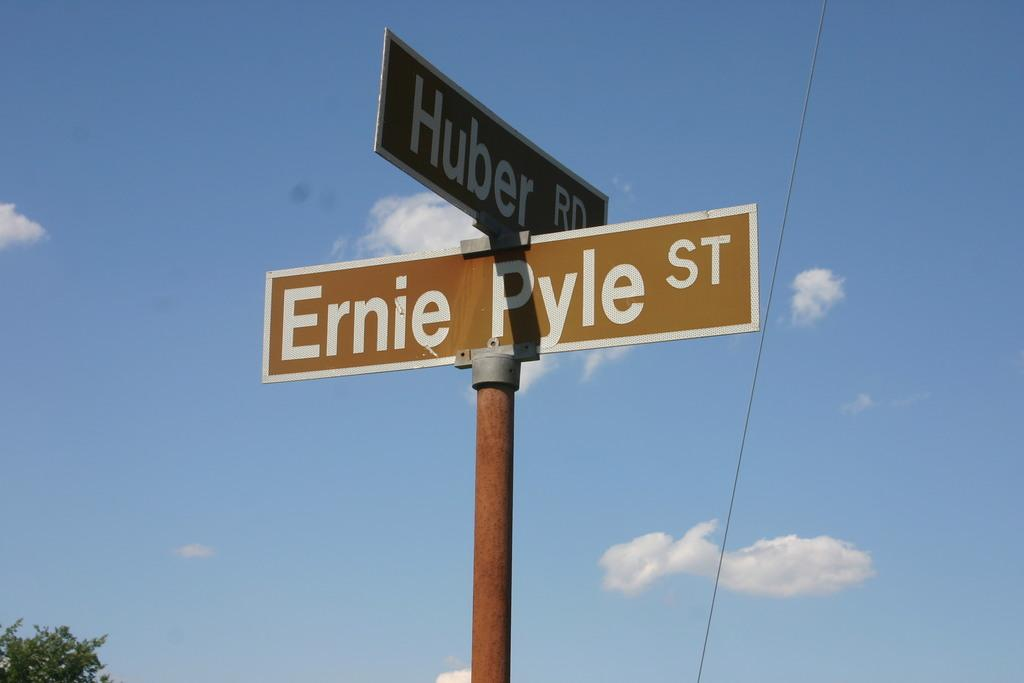<image>
Create a compact narrative representing the image presented. a sign that says ernie pyle on it 